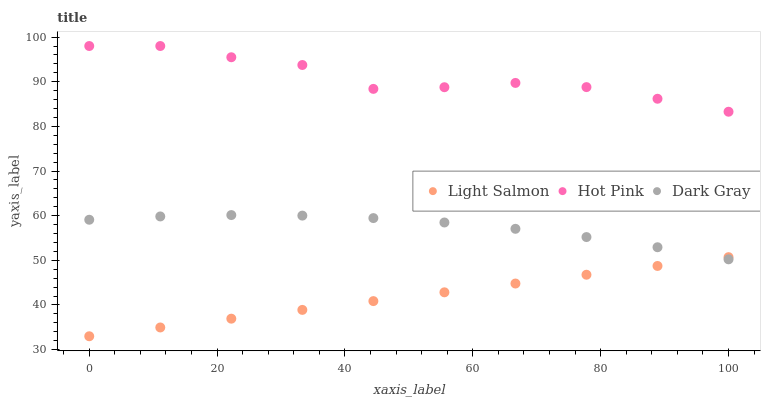Does Light Salmon have the minimum area under the curve?
Answer yes or no. Yes. Does Hot Pink have the maximum area under the curve?
Answer yes or no. Yes. Does Hot Pink have the minimum area under the curve?
Answer yes or no. No. Does Light Salmon have the maximum area under the curve?
Answer yes or no. No. Is Light Salmon the smoothest?
Answer yes or no. Yes. Is Hot Pink the roughest?
Answer yes or no. Yes. Is Hot Pink the smoothest?
Answer yes or no. No. Is Light Salmon the roughest?
Answer yes or no. No. Does Light Salmon have the lowest value?
Answer yes or no. Yes. Does Hot Pink have the lowest value?
Answer yes or no. No. Does Hot Pink have the highest value?
Answer yes or no. Yes. Does Light Salmon have the highest value?
Answer yes or no. No. Is Light Salmon less than Hot Pink?
Answer yes or no. Yes. Is Hot Pink greater than Dark Gray?
Answer yes or no. Yes. Does Dark Gray intersect Light Salmon?
Answer yes or no. Yes. Is Dark Gray less than Light Salmon?
Answer yes or no. No. Is Dark Gray greater than Light Salmon?
Answer yes or no. No. Does Light Salmon intersect Hot Pink?
Answer yes or no. No. 